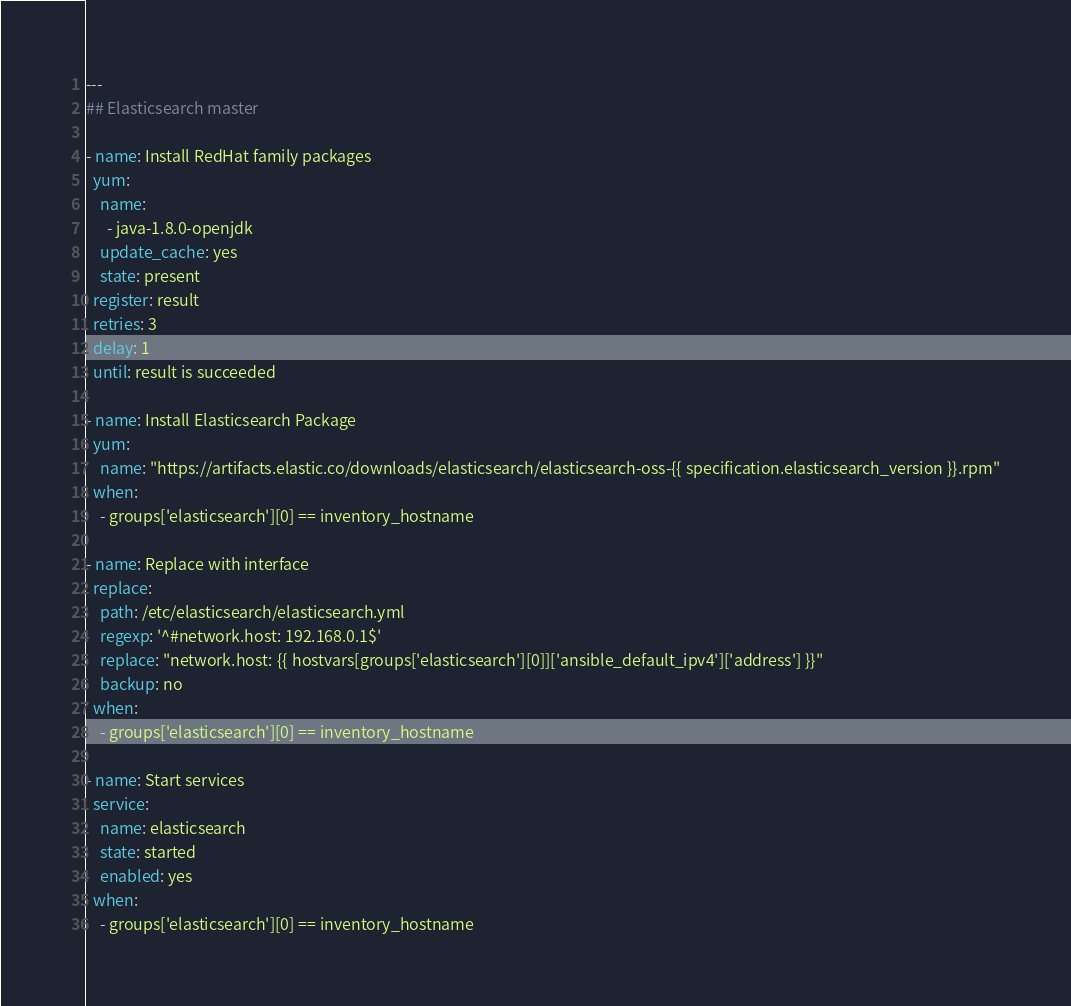<code> <loc_0><loc_0><loc_500><loc_500><_YAML_>---
## Elasticsearch master

- name: Install RedHat family packages
  yum:
    name:
      - java-1.8.0-openjdk
    update_cache: yes
    state: present
  register: result
  retries: 3
  delay: 1
  until: result is succeeded

- name: Install Elasticsearch Package
  yum:
    name: "https://artifacts.elastic.co/downloads/elasticsearch/elasticsearch-oss-{{ specification.elasticsearch_version }}.rpm"
  when:
    - groups['elasticsearch'][0] == inventory_hostname

- name: Replace with interface
  replace:
    path: /etc/elasticsearch/elasticsearch.yml
    regexp: '^#network.host: 192.168.0.1$'
    replace: "network.host: {{ hostvars[groups['elasticsearch'][0]]['ansible_default_ipv4']['address'] }}"
    backup: no
  when:
    - groups['elasticsearch'][0] == inventory_hostname

- name: Start services
  service:
    name: elasticsearch
    state: started
    enabled: yes
  when:
    - groups['elasticsearch'][0] == inventory_hostname
</code> 